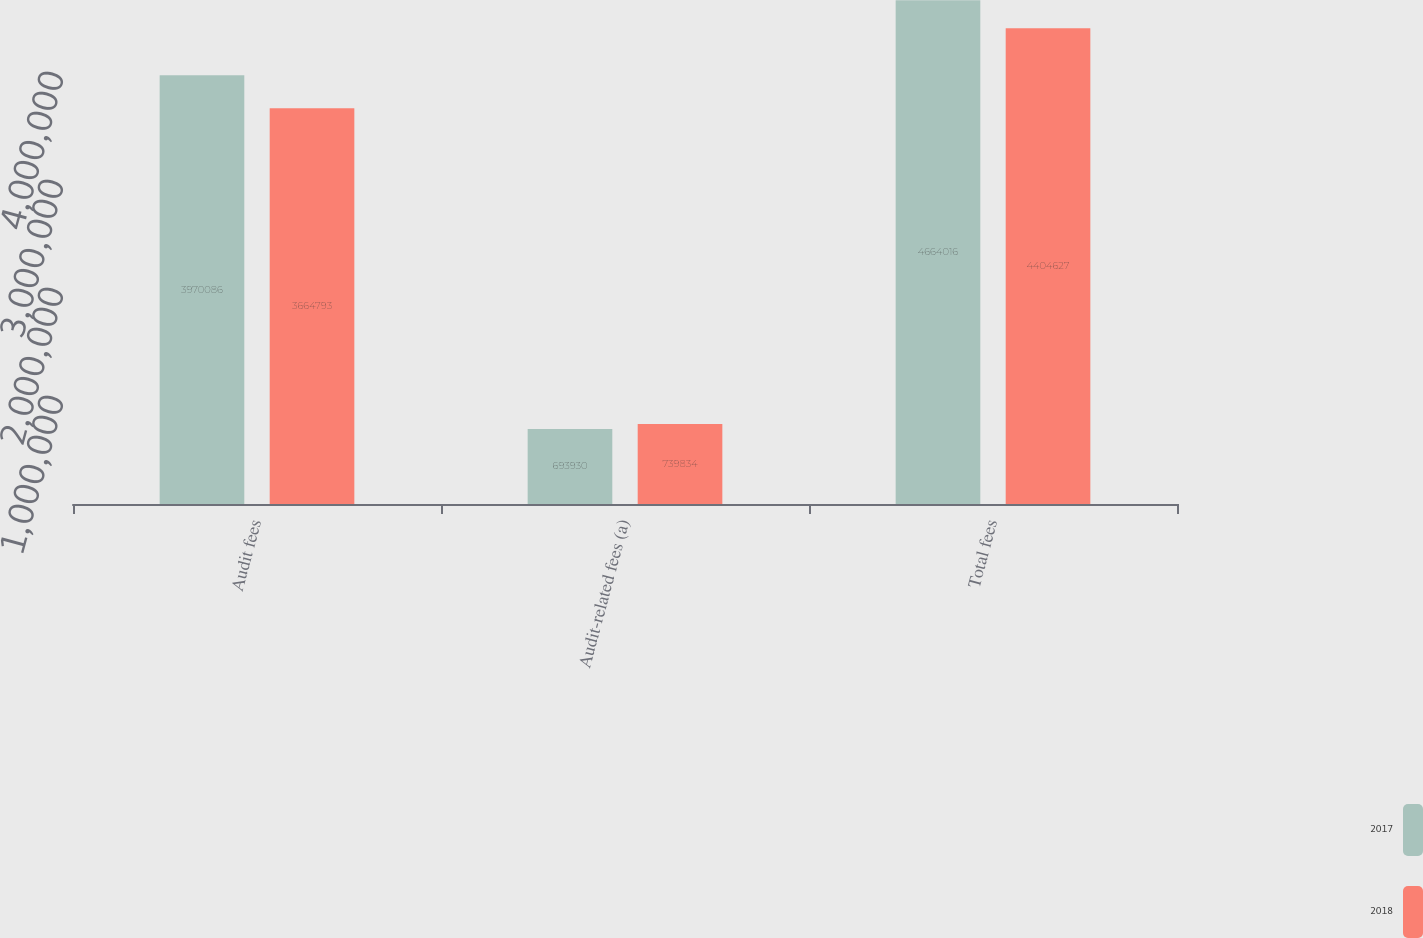<chart> <loc_0><loc_0><loc_500><loc_500><stacked_bar_chart><ecel><fcel>Audit fees<fcel>Audit-related fees (a)<fcel>Total fees<nl><fcel>2017<fcel>3.97009e+06<fcel>693930<fcel>4.66402e+06<nl><fcel>2018<fcel>3.66479e+06<fcel>739834<fcel>4.40463e+06<nl></chart> 